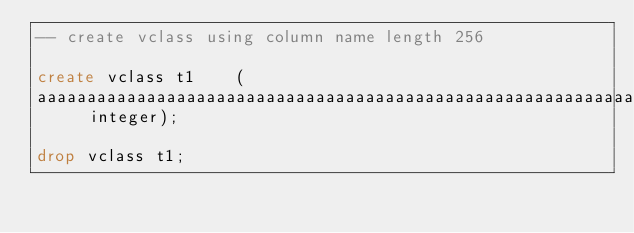Convert code to text. <code><loc_0><loc_0><loc_500><loc_500><_SQL_>-- create vclass using column name length 256 

create vclass t1 	( 
aaaaaaaaaaaaaaaaaaaaaaaaaaaaaaaaaaaaaaaaaaaaaaaaaaaaaaaaaaaaaaaaaaaaaaaaaaaaaaaaaaaaaaaaaaaaaaaaaaaaaaaaaaaaaaaaaaaaaaaaaaaaaaaaaaaaaaaaaaaaaaaaaaaaaaaaaaaaaaaaaaaaaaaaaaaaaaaaaaaaaaaaaaaaaaaaaaaaaaaaaaaaaaaaaaaaaaaaaaaaaaaaaaaaaaaaaaaaaaaaaaaaaaaaaaaaaaa	 integer);

drop vclass t1;</code> 